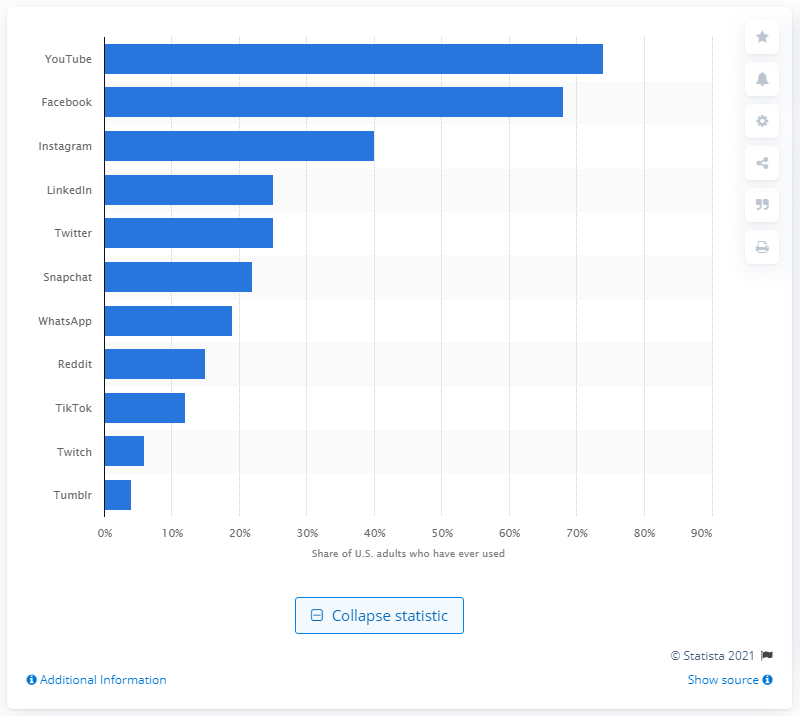Indicate a few pertinent items in this graphic. Second in the U.S. in September 2020 was Facebook, according to the website. 